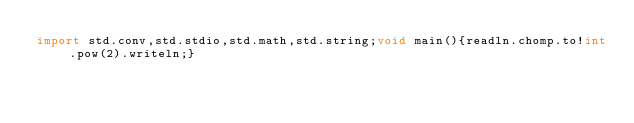Convert code to text. <code><loc_0><loc_0><loc_500><loc_500><_D_>import std.conv,std.stdio,std.math,std.string;void main(){readln.chomp.to!int.pow(2).writeln;}</code> 